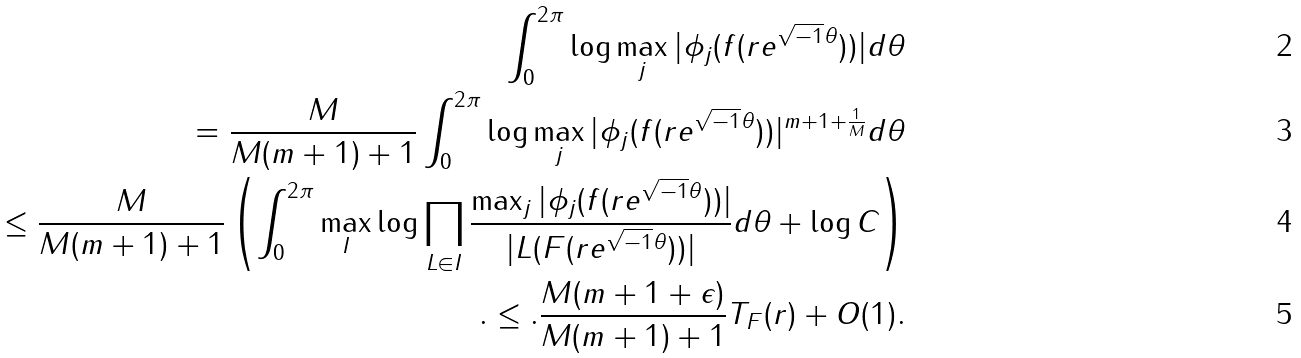<formula> <loc_0><loc_0><loc_500><loc_500>\int _ { 0 } ^ { 2 \pi } \log \max _ { j } | \phi _ { j } ( f ( r e ^ { \sqrt { - 1 } \theta } ) ) | d \theta \\ = \frac { M } { M ( m + 1 ) + 1 } \int _ { 0 } ^ { 2 \pi } \log \max _ { j } | \phi _ { j } ( f ( r e ^ { \sqrt { - 1 } \theta } ) ) | ^ { m + 1 + \frac { 1 } { M } } d \theta \\ \leq \frac { M } { M ( m + 1 ) + 1 } \left ( \int _ { 0 } ^ { 2 \pi } \max _ { I } \log { \prod _ { L \in I } \frac { \max _ { j } | \phi _ { j } ( f ( r e ^ { \sqrt { - 1 } \theta } ) ) | } { | L ( F ( r e ^ { \sqrt { - 1 } \theta } ) ) | } } d \theta + \log C \right ) \\ . \leq . \frac { M ( m + 1 + \epsilon ) } { M ( m + 1 ) + 1 } T _ { F } ( r ) + O ( 1 ) .</formula> 